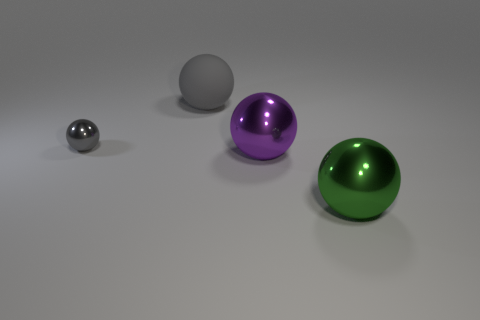Subtract 1 spheres. How many spheres are left? 3 Subtract all brown balls. Subtract all purple cubes. How many balls are left? 4 Add 4 big green metallic cylinders. How many objects exist? 8 Subtract all large red rubber cylinders. Subtract all gray matte things. How many objects are left? 3 Add 2 gray spheres. How many gray spheres are left? 4 Add 2 small shiny objects. How many small shiny objects exist? 3 Subtract 0 brown spheres. How many objects are left? 4 